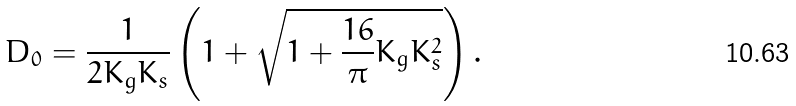Convert formula to latex. <formula><loc_0><loc_0><loc_500><loc_500>D _ { 0 } = \frac { 1 } { 2 K _ { g } K _ { s } } \left ( 1 + \sqrt { 1 + \frac { 1 6 } { \pi } K _ { g } K _ { s } ^ { 2 } } \right ) .</formula> 